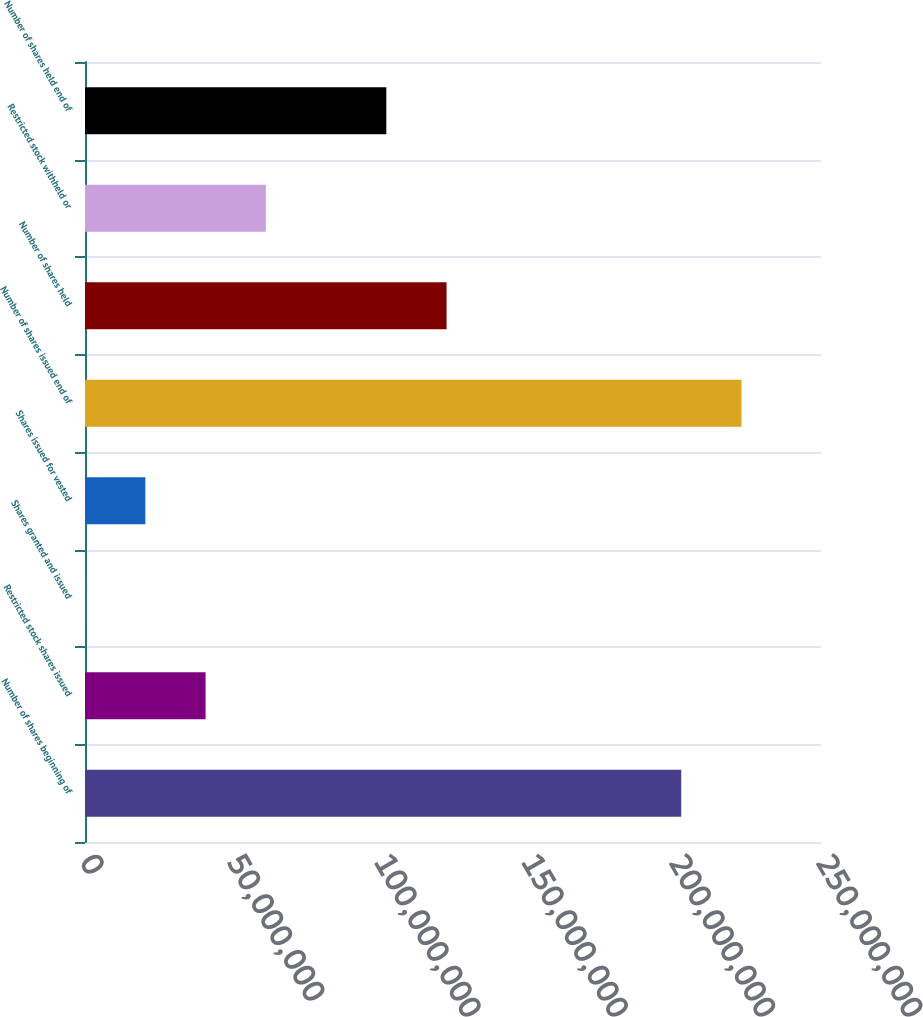Convert chart. <chart><loc_0><loc_0><loc_500><loc_500><bar_chart><fcel>Number of shares beginning of<fcel>Restricted stock shares issued<fcel>Shares granted and issued<fcel>Shares issued for vested<fcel>Number of shares issued end of<fcel>Number of shares held<fcel>Restricted stock withheld or<fcel>Number of shares held end of<nl><fcel>2.02529e+08<fcel>4.09624e+07<fcel>37824<fcel>2.05001e+07<fcel>2.22991e+08<fcel>1.22812e+08<fcel>6.14247e+07<fcel>1.02349e+08<nl></chart> 